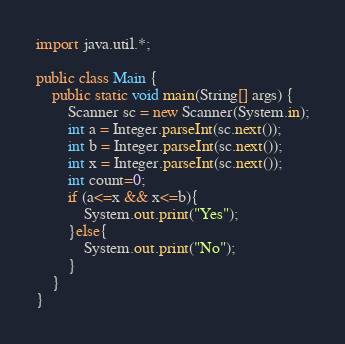Convert code to text. <code><loc_0><loc_0><loc_500><loc_500><_Java_>import java.util.*;

public class Main {
    public static void main(String[] args) {
        Scanner sc = new Scanner(System.in);
        int a = Integer.parseInt(sc.next());
        int b = Integer.parseInt(sc.next());
        int x = Integer.parseInt(sc.next());
		int count=0;
		if (a<=x && x<=b){
			System.out.print("Yes");
        }else{
        	System.out.print("No");
        }
    }
}</code> 